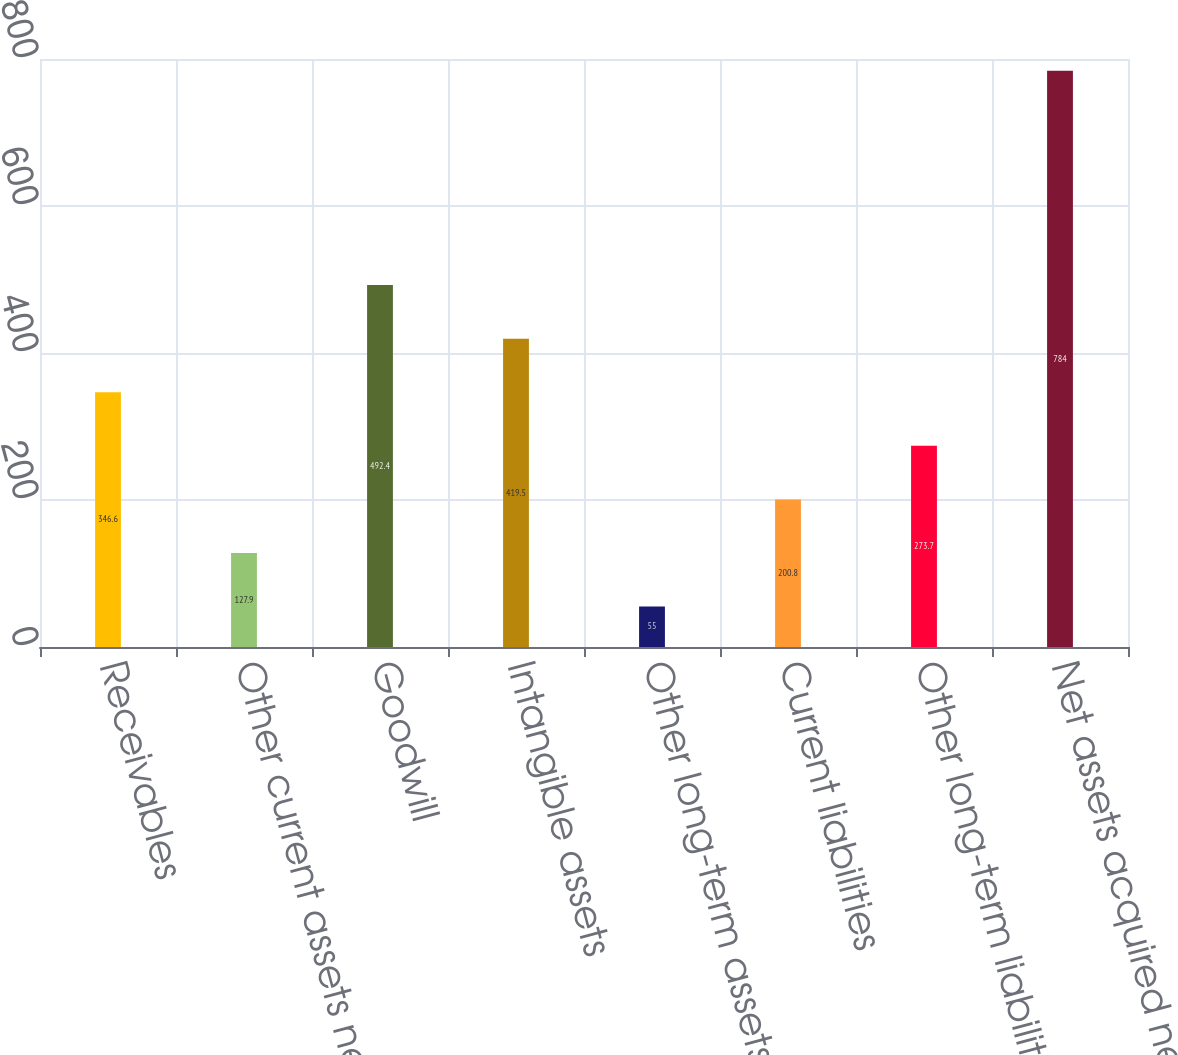Convert chart. <chart><loc_0><loc_0><loc_500><loc_500><bar_chart><fcel>Receivables<fcel>Other current assets net of<fcel>Goodwill<fcel>Intangible assets<fcel>Other long-term assets<fcel>Current liabilities<fcel>Other long-term liabilities<fcel>Net assets acquired net of<nl><fcel>346.6<fcel>127.9<fcel>492.4<fcel>419.5<fcel>55<fcel>200.8<fcel>273.7<fcel>784<nl></chart> 